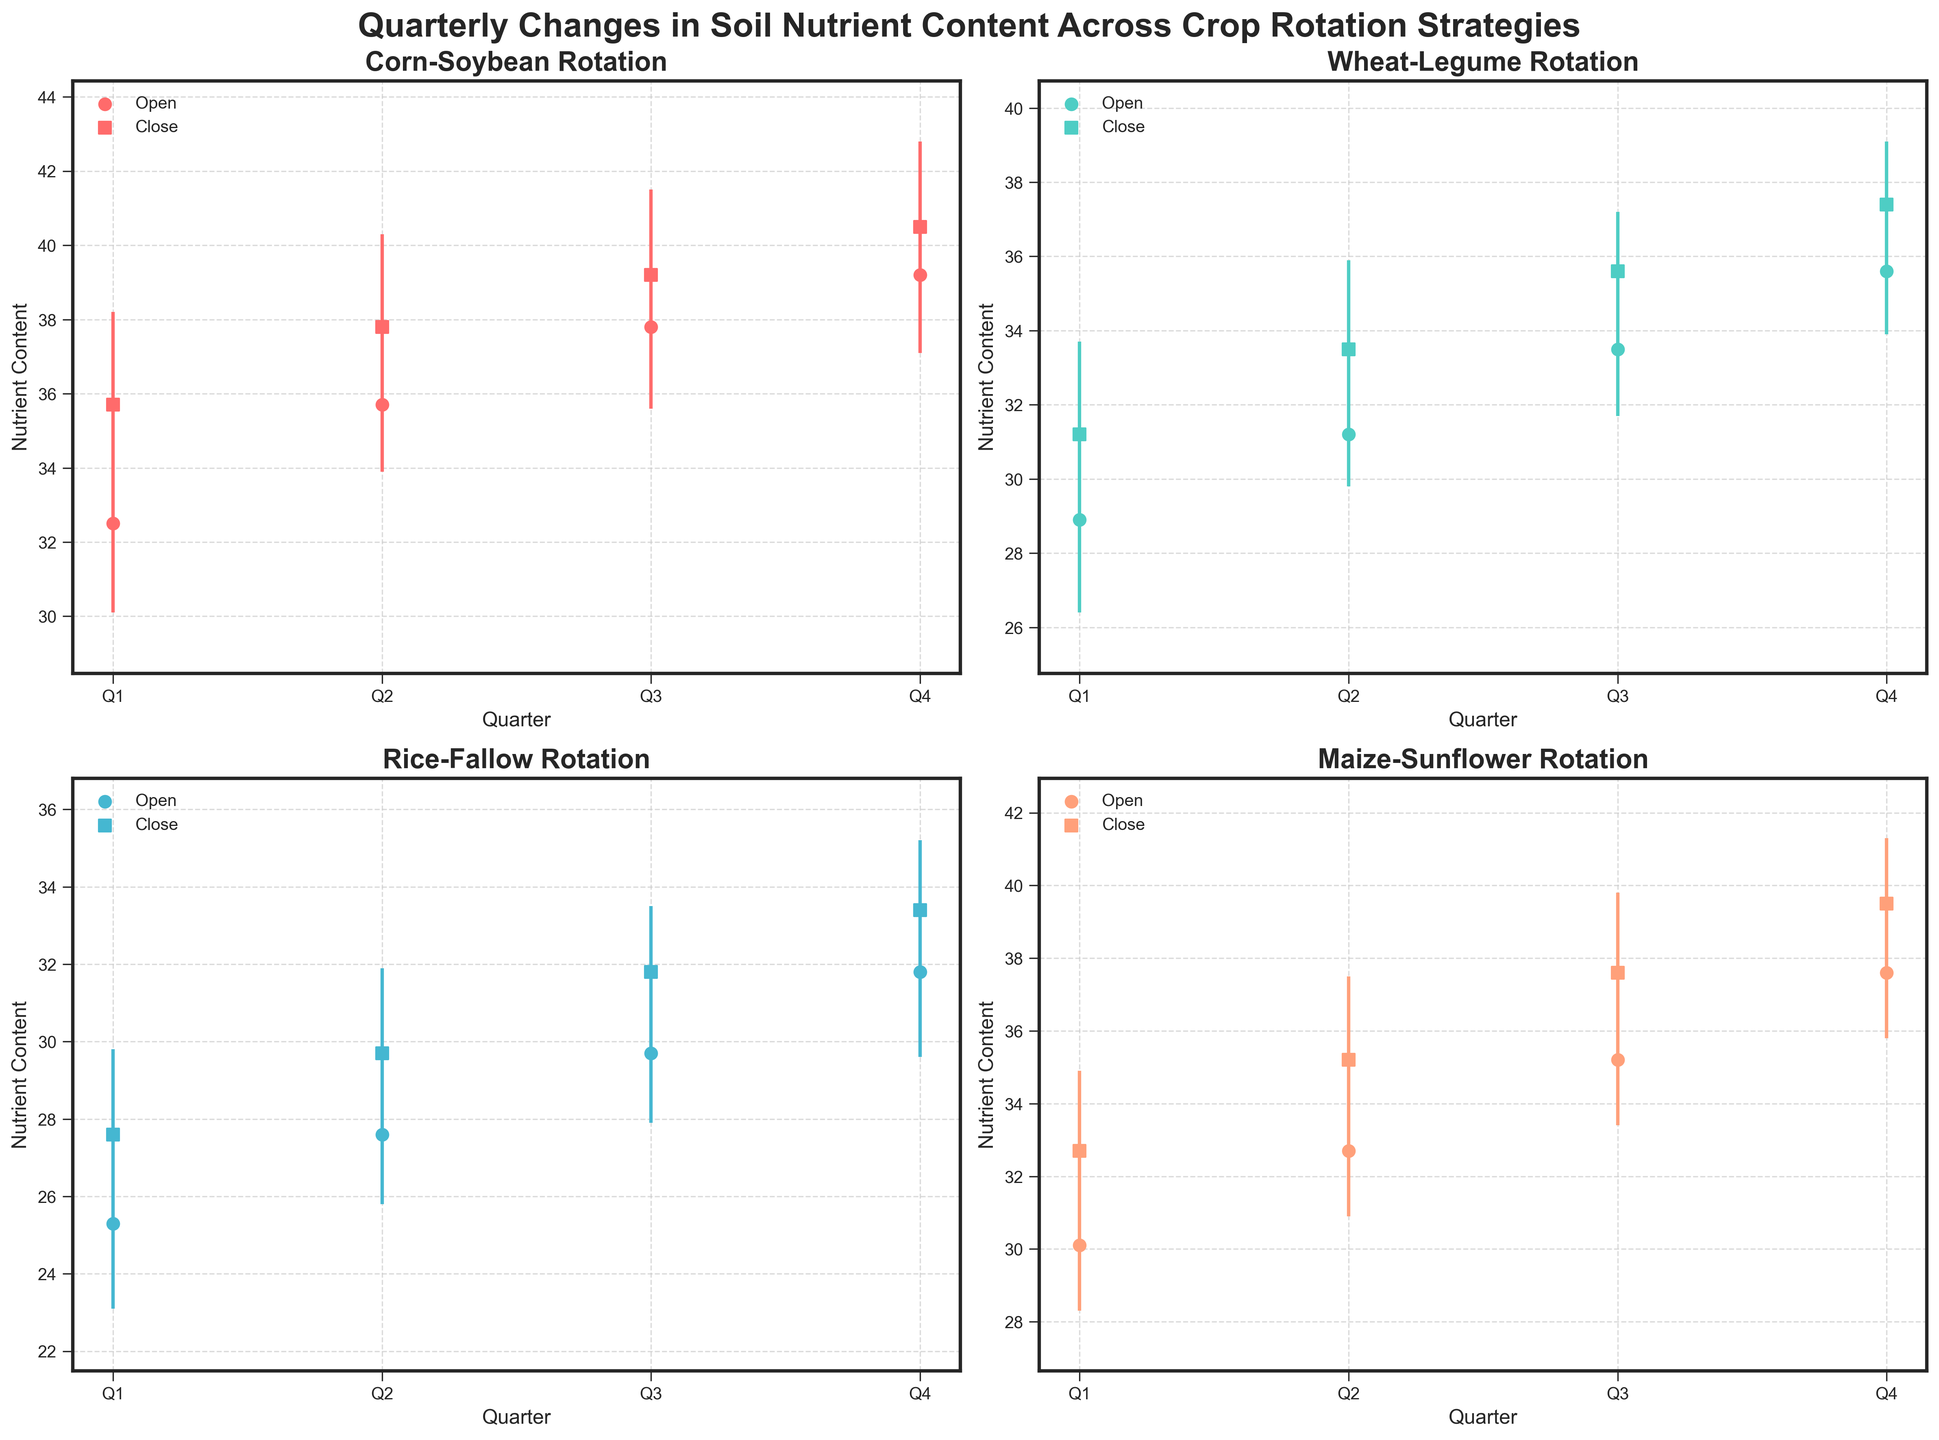What is the title of the figure? The title is located at the top center of the figure and reads "Quarterly Changes in Soil Nutrient Content Across Crop Rotation Strategies".
Answer: Quarterly Changes in Soil Nutrient Content Across Crop Rotation Strategies How many different crop rotations are being analyzed in the figure? Each subplot represents a different crop rotation strategy. There are a total of four subplots, indicating four different crop rotations.
Answer: Four What does the marker 'o' signify in the plots? The scatter markers 'o' represent the open nutrient content values for each quarter, as denoted in the legend.
Answer: open values In which quarter did the Corn-Soybean rotation achieve its highest nutrient content? For Corn-Soybean, the high value peaks in Q4 as indicated by the vertical line reaching the highest value on the y-axis in that subplot.
Answer: Q4 How does the Q2 close value for Rice-Fallow compare to its Q1 open value? To find the comparison, observe the Rice-Fallow subplot. The Q2 close value is 29.7, and the Q1 open value is 25.3. Comparing both, 29.7 is higher than 25.3.
Answer: Higher Which crop rotation shows the smallest increment in its close value from Q1 to Q4? Calculate the difference between Q4 and Q1 close values for each rotation. Corn-Soybean: 40.5-35.7 = 4.8, Wheat-Legume: 37.4-31.2 = 6.2, Rice-Fallow: 33.4-27.6 = 5.8, Maize-Sunflower: 39.5-32.7 = 6.8. The smallest increment is 4.8 for Corn-Soybean.
Answer: Corn-Soybean During which quarter does Wheat-Legume have the smallest range in nutrient content? The range is calculated by subtracting the low value from the high value for each quarter in Wheat-Legume. Q1: 33.7-26.4=7.3, Q2: 35.9-29.8=6.1, Q3: 37.2-31.7=5.5, Q4: 39.1-33.9=5.2. The smallest range is in Q4 with a range of 5.2.
Answer: Q4 Which crop rotation showed the highest nutrient content at any point in any quarter? Examine the high values across all subplots. Corn-Soybean reaches a high of 42.8 in Q4, Wheat-Legume 39.1 in Q4, Rice-Fallow 35.2 in Q4, Maize-Sunflower 41.3 in Q4. The highest value is 42.8 for Corn-Soybean.
Answer: Corn-Soybean 